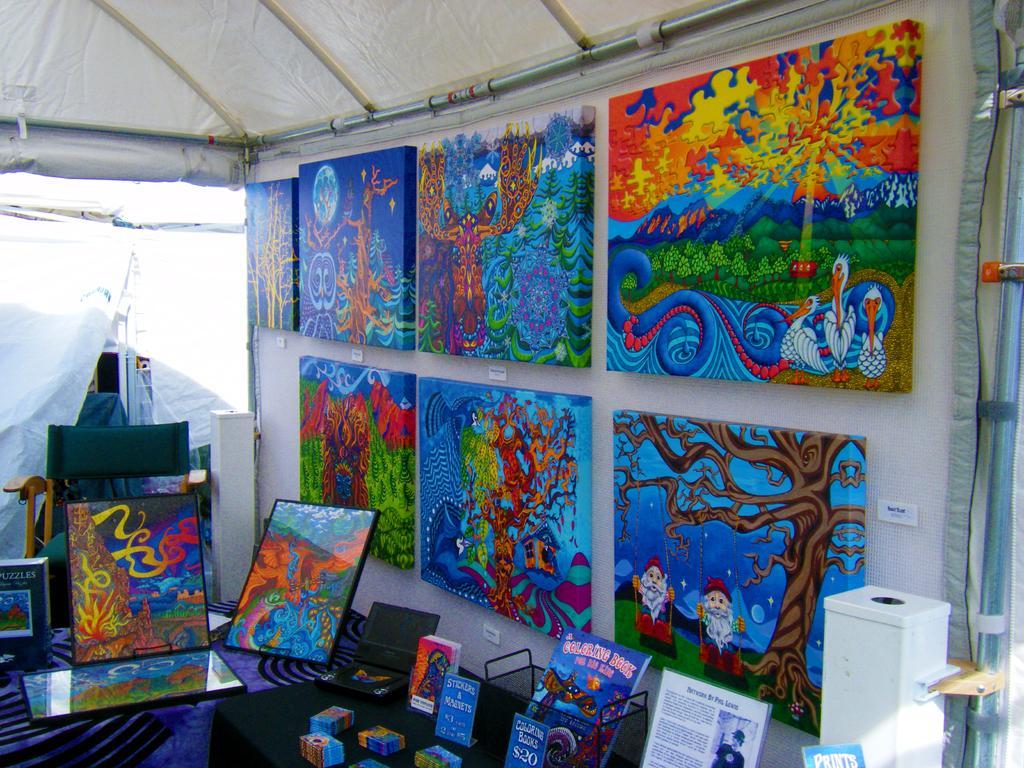Can you describe this image briefly? In this picture I can observe some paintings in the middle of the picture. These paintings are in blue, brown, red, orange and white colors. I can observe white color tent in the top of the picture. 